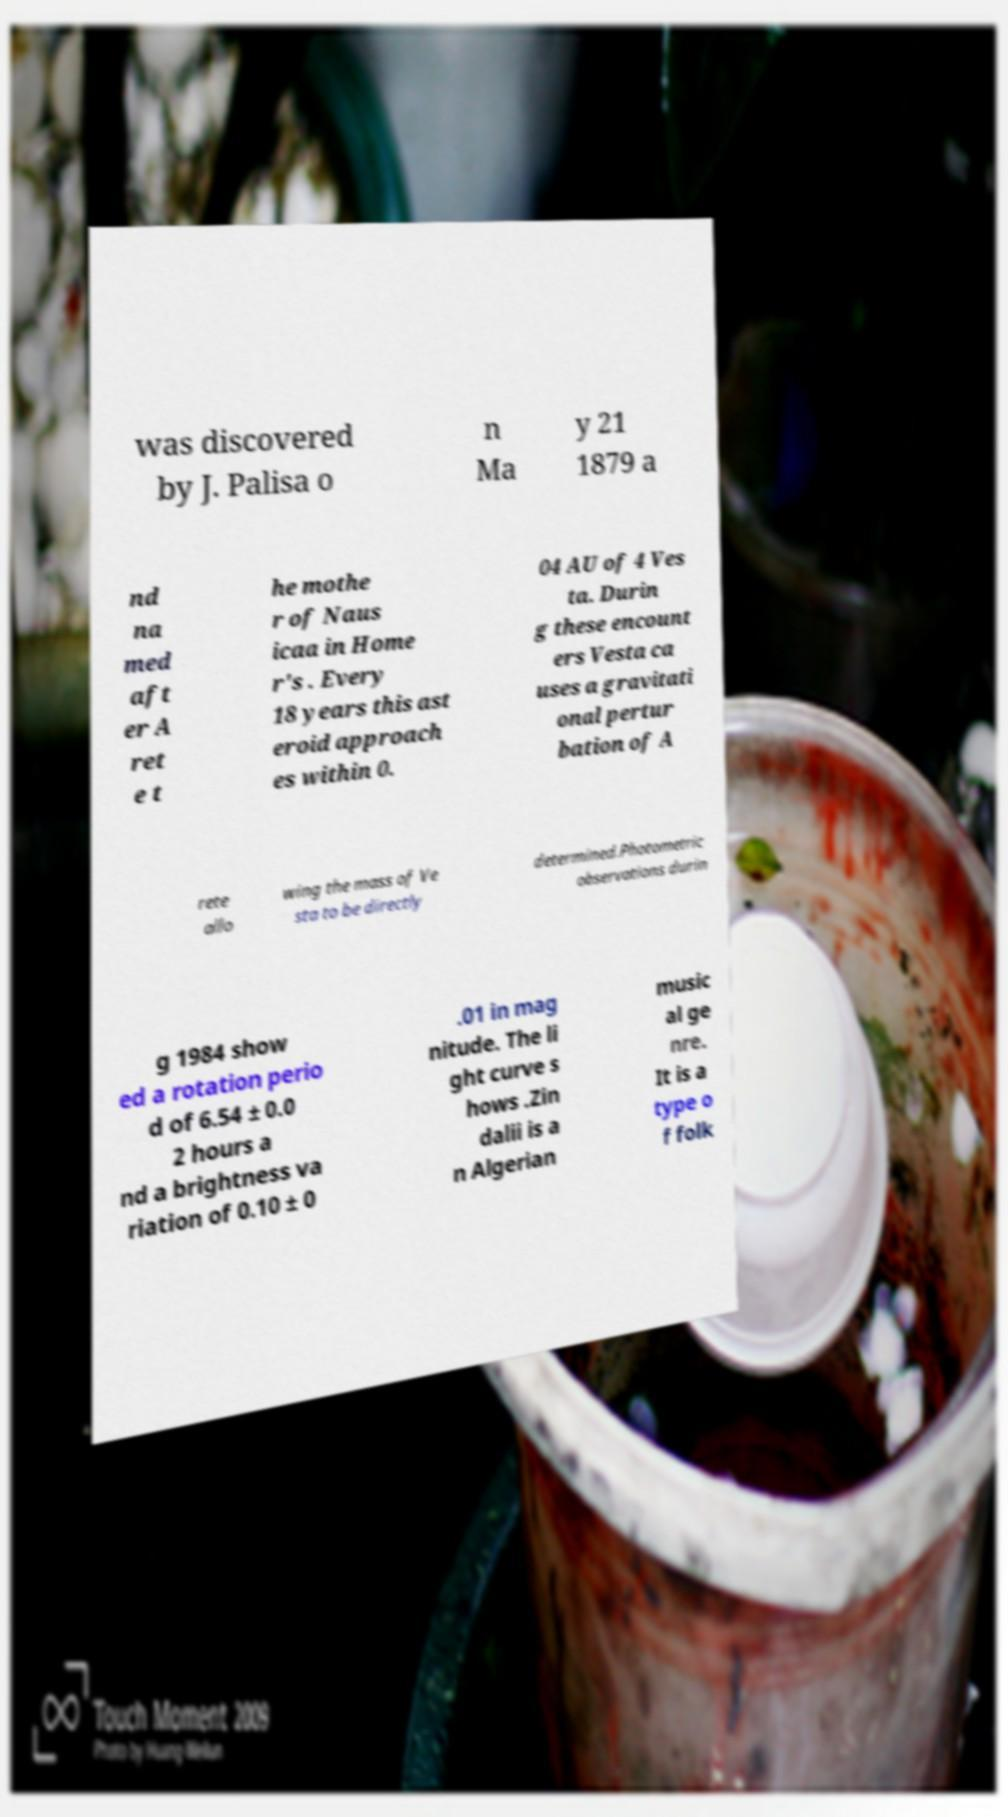For documentation purposes, I need the text within this image transcribed. Could you provide that? was discovered by J. Palisa o n Ma y 21 1879 a nd na med aft er A ret e t he mothe r of Naus icaa in Home r's . Every 18 years this ast eroid approach es within 0. 04 AU of 4 Ves ta. Durin g these encount ers Vesta ca uses a gravitati onal pertur bation of A rete allo wing the mass of Ve sta to be directly determined.Photometric observations durin g 1984 show ed a rotation perio d of 6.54 ± 0.0 2 hours a nd a brightness va riation of 0.10 ± 0 .01 in mag nitude. The li ght curve s hows .Zin dalii is a n Algerian music al ge nre. It is a type o f folk 